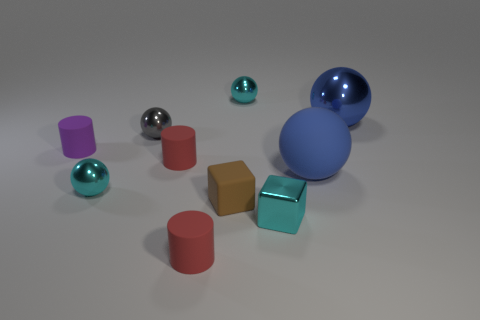Subtract all blue blocks. Subtract all cyan cylinders. How many blocks are left? 2 Subtract all yellow cylinders. How many brown balls are left? 0 Add 5 objects. How many small cyans exist? 0 Subtract all tiny red rubber cylinders. Subtract all red cylinders. How many objects are left? 6 Add 8 small rubber cubes. How many small rubber cubes are left? 9 Add 1 green matte cylinders. How many green matte cylinders exist? 1 Subtract all cyan cubes. How many cubes are left? 1 Subtract all big blue metallic balls. How many balls are left? 4 Subtract 0 green cubes. How many objects are left? 10 Subtract all blocks. How many objects are left? 8 